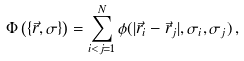<formula> <loc_0><loc_0><loc_500><loc_500>\Phi \left ( \{ \vec { r } , \sigma \} \right ) = \sum _ { i < j = 1 } ^ { N } \phi ( | \vec { r } _ { i } - \vec { r } _ { j } | , \sigma _ { i } , \sigma _ { j } ) \, ,</formula> 